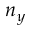Convert formula to latex. <formula><loc_0><loc_0><loc_500><loc_500>n _ { y }</formula> 